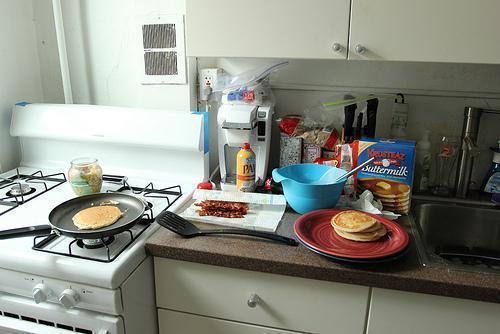How many people are standing the kitchen?
Give a very brief answer. 0. 